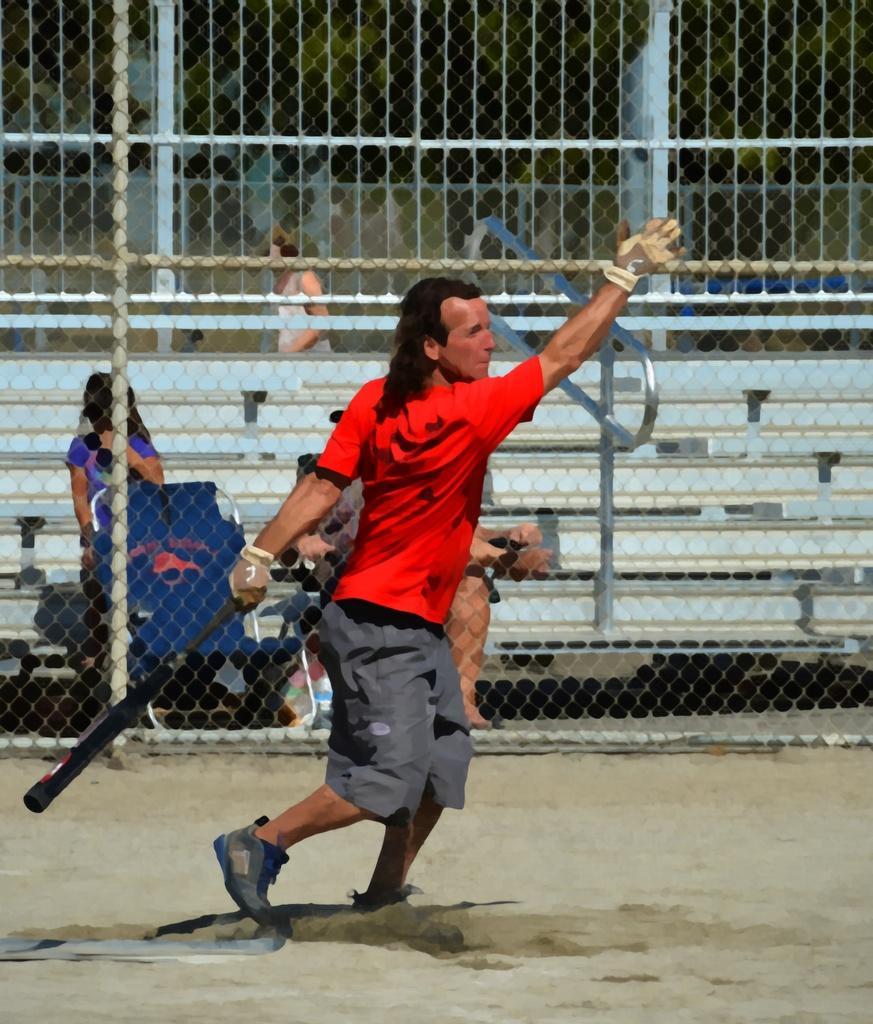Can you describe this image briefly? This is an edited image. In front of the picture, we see a man in the red T-shirt is holding a baseball bat in his hands. At the bottom, we see the sand. Behind him, we see the poles and the fence and behind that, we see two people are sitting on the staircase and we see the stair railing. Behind that, we see a woman is standing. In the background, we see a wall. 